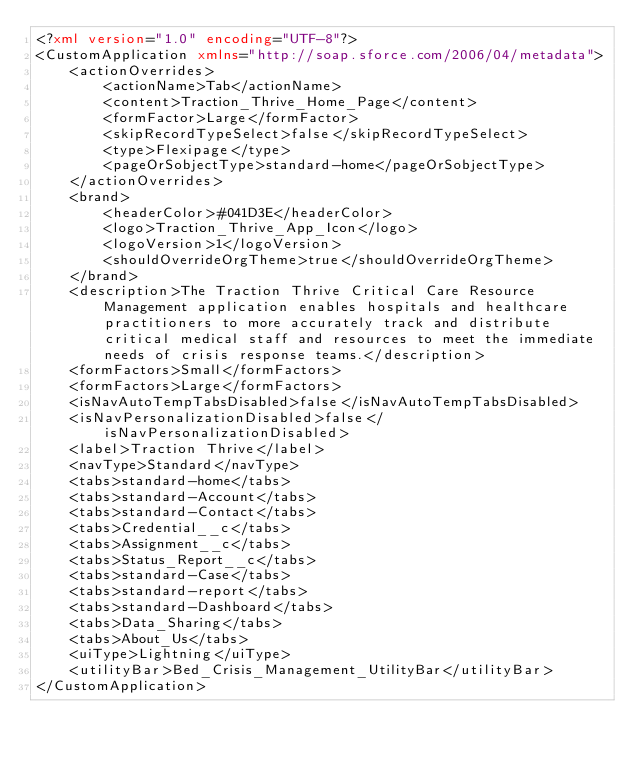Convert code to text. <code><loc_0><loc_0><loc_500><loc_500><_XML_><?xml version="1.0" encoding="UTF-8"?>
<CustomApplication xmlns="http://soap.sforce.com/2006/04/metadata">
    <actionOverrides>
        <actionName>Tab</actionName>
        <content>Traction_Thrive_Home_Page</content>
        <formFactor>Large</formFactor>
        <skipRecordTypeSelect>false</skipRecordTypeSelect>
        <type>Flexipage</type>
        <pageOrSobjectType>standard-home</pageOrSobjectType>
    </actionOverrides>
    <brand>
        <headerColor>#041D3E</headerColor>
        <logo>Traction_Thrive_App_Icon</logo>
        <logoVersion>1</logoVersion>
        <shouldOverrideOrgTheme>true</shouldOverrideOrgTheme>
    </brand>
    <description>The Traction Thrive Critical Care Resource Management application enables hospitals and healthcare practitioners to more accurately track and distribute critical medical staff and resources to meet the immediate needs of crisis response teams.</description>
    <formFactors>Small</formFactors>
    <formFactors>Large</formFactors>
    <isNavAutoTempTabsDisabled>false</isNavAutoTempTabsDisabled>
    <isNavPersonalizationDisabled>false</isNavPersonalizationDisabled>
    <label>Traction Thrive</label>
    <navType>Standard</navType>
    <tabs>standard-home</tabs>
    <tabs>standard-Account</tabs>
    <tabs>standard-Contact</tabs>
    <tabs>Credential__c</tabs>
    <tabs>Assignment__c</tabs>
    <tabs>Status_Report__c</tabs>
    <tabs>standard-Case</tabs>
    <tabs>standard-report</tabs>
    <tabs>standard-Dashboard</tabs>
    <tabs>Data_Sharing</tabs>
    <tabs>About_Us</tabs>
    <uiType>Lightning</uiType>
    <utilityBar>Bed_Crisis_Management_UtilityBar</utilityBar>
</CustomApplication>
</code> 